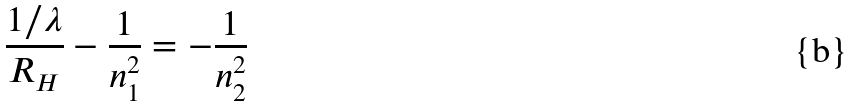<formula> <loc_0><loc_0><loc_500><loc_500>\frac { 1 / \lambda } { R _ { H } } - \frac { 1 } { n _ { 1 } ^ { 2 } } = - \frac { 1 } { n _ { 2 } ^ { 2 } }</formula> 